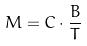Convert formula to latex. <formula><loc_0><loc_0><loc_500><loc_500>M = C \cdot \frac { B } { T }</formula> 